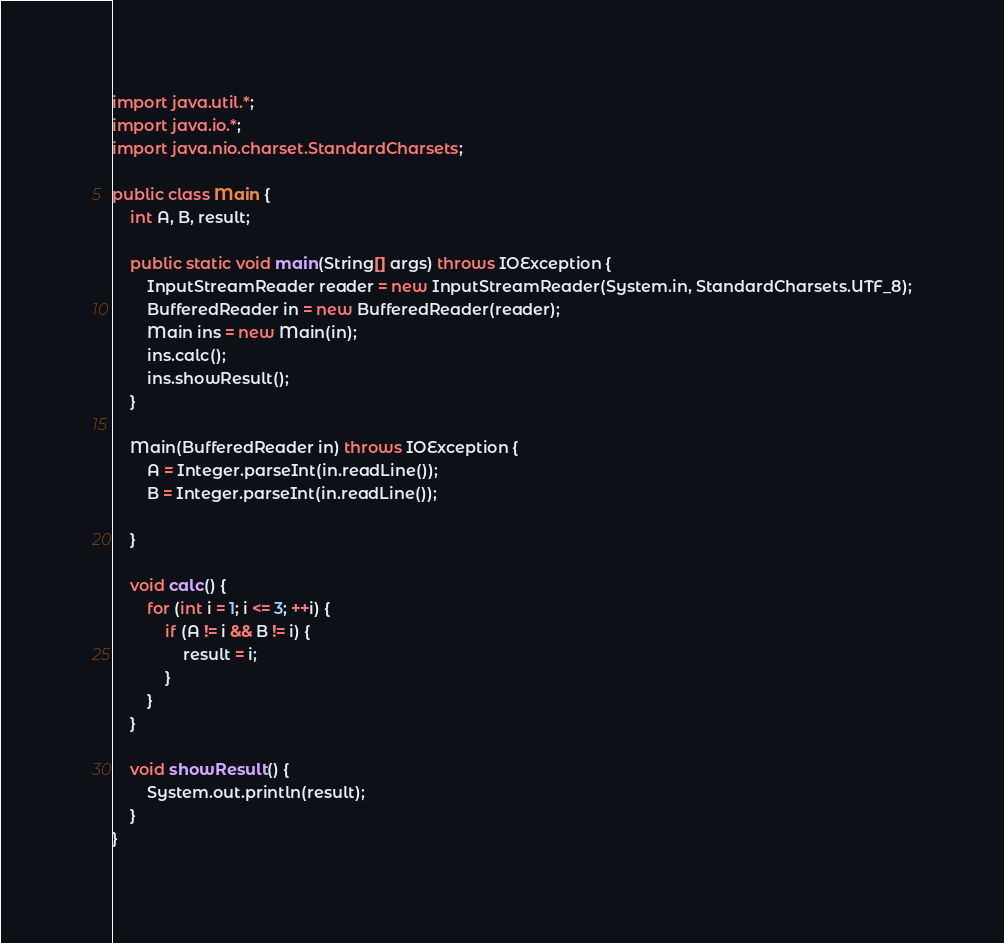Convert code to text. <code><loc_0><loc_0><loc_500><loc_500><_Java_>import java.util.*;
import java.io.*;
import java.nio.charset.StandardCharsets;

public class Main {
	int A, B, result;

	public static void main(String[] args) throws IOException {
		InputStreamReader reader = new InputStreamReader(System.in, StandardCharsets.UTF_8);
		BufferedReader in = new BufferedReader(reader);
		Main ins = new Main(in);
		ins.calc();
		ins.showResult();
	}

	Main(BufferedReader in) throws IOException {
		A = Integer.parseInt(in.readLine());
		B = Integer.parseInt(in.readLine());

	}

	void calc() {
		for (int i = 1; i <= 3; ++i) {
			if (A != i && B != i) {
				result = i;
			}
		}
	}

	void showResult() {
		System.out.println(result);
	}
}
</code> 